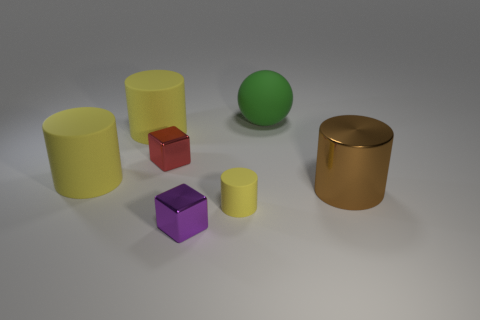What material is the small block that is left of the tiny shiny block on the right side of the small shiny cube behind the brown metallic object?
Offer a terse response. Metal. What number of objects are small yellow rubber things or large brown shiny cylinders?
Offer a terse response. 2. Is there any other thing that has the same material as the green thing?
Offer a very short reply. Yes. The purple thing has what shape?
Your answer should be compact. Cube. What is the shape of the small shiny object in front of the big cylinder to the right of the large matte ball?
Your answer should be very brief. Cube. Is the big cylinder that is behind the red metallic cube made of the same material as the brown cylinder?
Provide a short and direct response. No. What number of blue things are either large rubber balls or tiny matte cylinders?
Provide a succinct answer. 0. Is there a sphere of the same color as the tiny cylinder?
Ensure brevity in your answer.  No. Is there a tiny yellow object made of the same material as the tiny yellow cylinder?
Provide a succinct answer. No. There is a thing that is in front of the large shiny cylinder and behind the small purple metallic block; what shape is it?
Your response must be concise. Cylinder. 